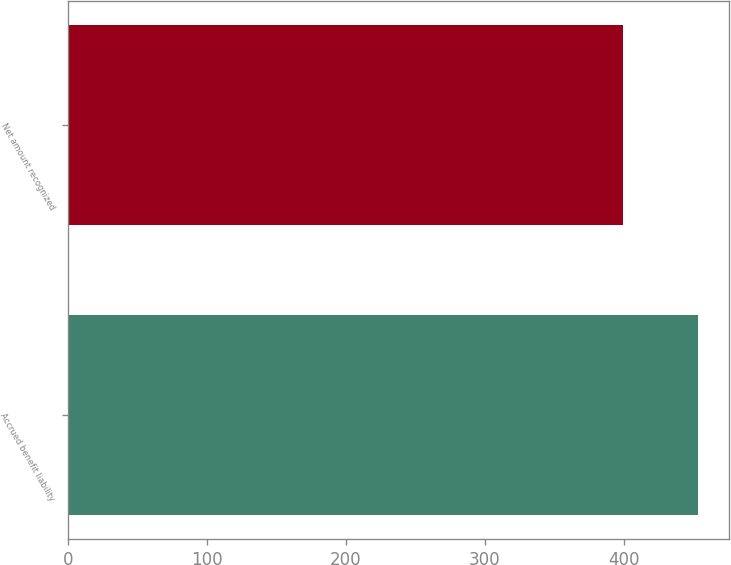<chart> <loc_0><loc_0><loc_500><loc_500><bar_chart><fcel>Accrued benefit liability<fcel>Net amount recognized<nl><fcel>453<fcel>399<nl></chart> 